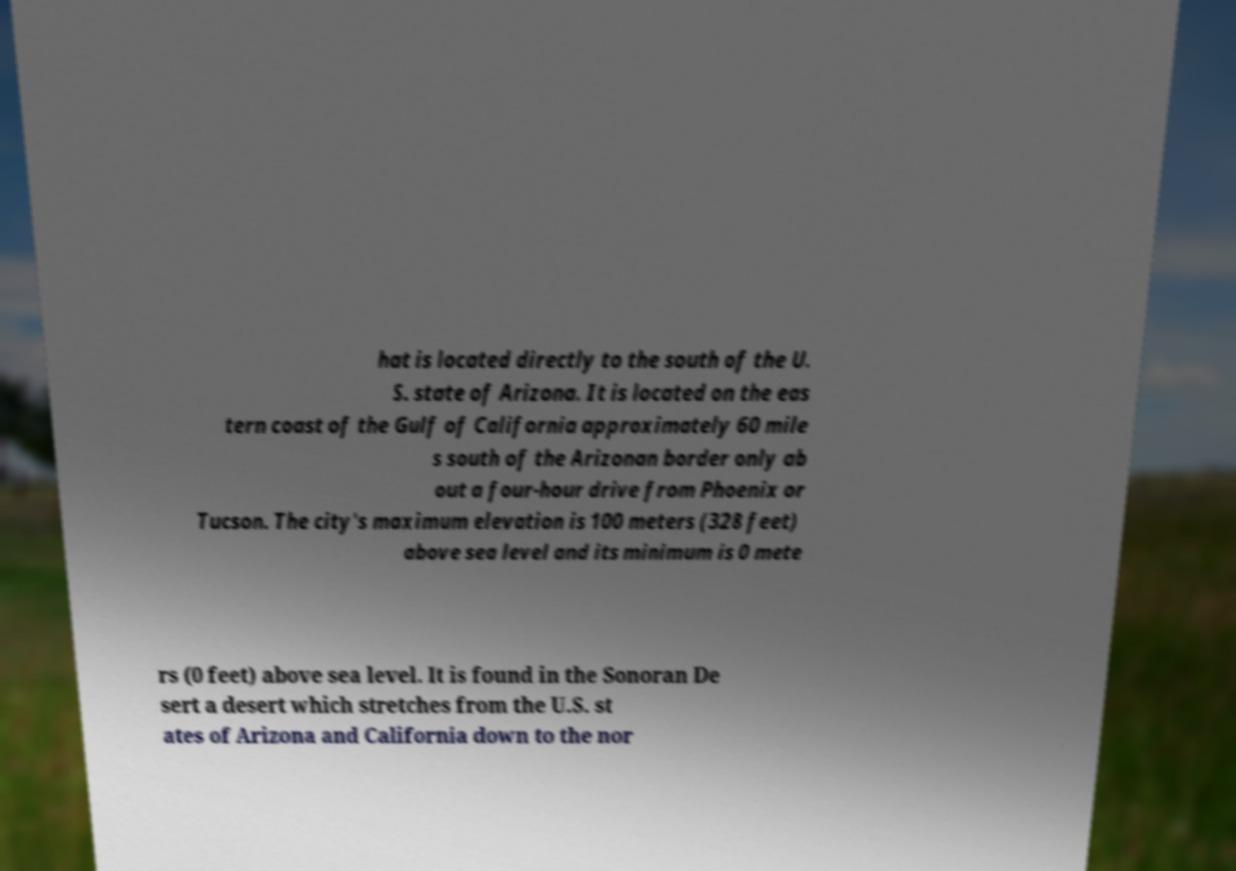What messages or text are displayed in this image? I need them in a readable, typed format. hat is located directly to the south of the U. S. state of Arizona. It is located on the eas tern coast of the Gulf of California approximately 60 mile s south of the Arizonan border only ab out a four-hour drive from Phoenix or Tucson. The city's maximum elevation is 100 meters (328 feet) above sea level and its minimum is 0 mete rs (0 feet) above sea level. It is found in the Sonoran De sert a desert which stretches from the U.S. st ates of Arizona and California down to the nor 